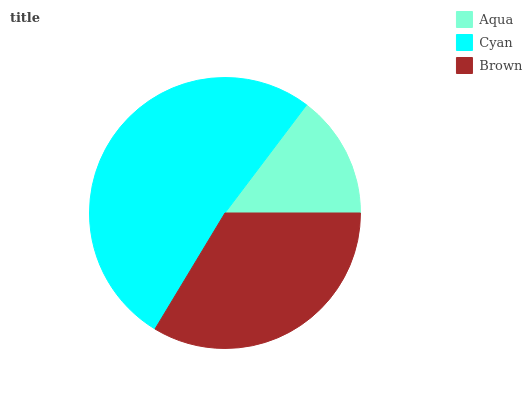Is Aqua the minimum?
Answer yes or no. Yes. Is Cyan the maximum?
Answer yes or no. Yes. Is Brown the minimum?
Answer yes or no. No. Is Brown the maximum?
Answer yes or no. No. Is Cyan greater than Brown?
Answer yes or no. Yes. Is Brown less than Cyan?
Answer yes or no. Yes. Is Brown greater than Cyan?
Answer yes or no. No. Is Cyan less than Brown?
Answer yes or no. No. Is Brown the high median?
Answer yes or no. Yes. Is Brown the low median?
Answer yes or no. Yes. Is Aqua the high median?
Answer yes or no. No. Is Aqua the low median?
Answer yes or no. No. 